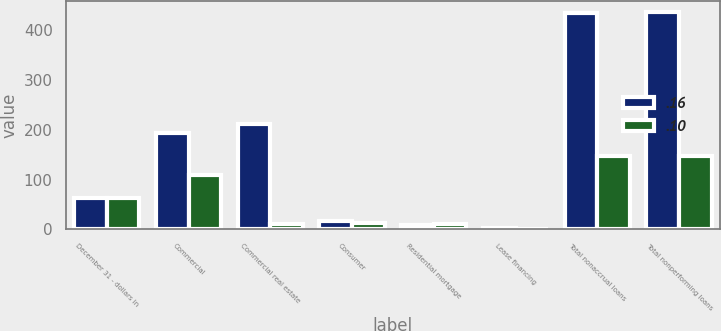Convert chart. <chart><loc_0><loc_0><loc_500><loc_500><stacked_bar_chart><ecel><fcel>December 31 - dollars in<fcel>Commercial<fcel>Commercial real estate<fcel>Consumer<fcel>Residential mortgage<fcel>Lease financing<fcel>Total nonaccrual loans<fcel>Total nonperforming loans<nl><fcel>0.16<fcel>63<fcel>193<fcel>212<fcel>17<fcel>10<fcel>3<fcel>435<fcel>437<nl><fcel>0.1<fcel>63<fcel>109<fcel>12<fcel>13<fcel>12<fcel>1<fcel>147<fcel>147<nl></chart> 